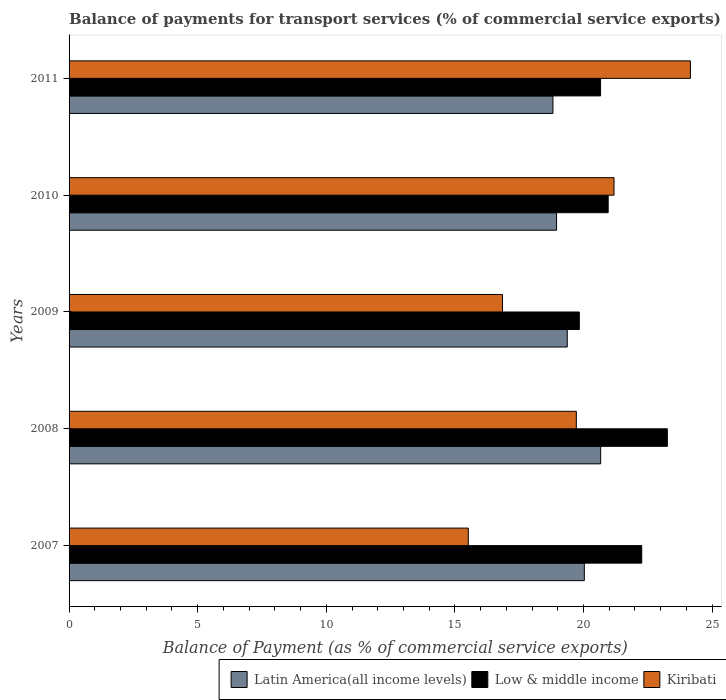How many different coloured bars are there?
Your response must be concise. 3. How many groups of bars are there?
Your answer should be compact. 5. Are the number of bars per tick equal to the number of legend labels?
Keep it short and to the point. Yes. How many bars are there on the 4th tick from the top?
Give a very brief answer. 3. What is the label of the 2nd group of bars from the top?
Offer a terse response. 2010. What is the balance of payments for transport services in Kiribati in 2011?
Offer a very short reply. 24.16. Across all years, what is the maximum balance of payments for transport services in Low & middle income?
Make the answer very short. 23.26. Across all years, what is the minimum balance of payments for transport services in Kiribati?
Keep it short and to the point. 15.52. What is the total balance of payments for transport services in Latin America(all income levels) in the graph?
Give a very brief answer. 97.83. What is the difference between the balance of payments for transport services in Latin America(all income levels) in 2008 and that in 2009?
Your answer should be compact. 1.3. What is the difference between the balance of payments for transport services in Low & middle income in 2011 and the balance of payments for transport services in Latin America(all income levels) in 2007?
Offer a terse response. 0.63. What is the average balance of payments for transport services in Latin America(all income levels) per year?
Your answer should be compact. 19.57. In the year 2007, what is the difference between the balance of payments for transport services in Kiribati and balance of payments for transport services in Low & middle income?
Offer a terse response. -6.74. In how many years, is the balance of payments for transport services in Kiribati greater than 2 %?
Make the answer very short. 5. What is the ratio of the balance of payments for transport services in Kiribati in 2007 to that in 2009?
Your response must be concise. 0.92. Is the balance of payments for transport services in Kiribati in 2007 less than that in 2009?
Offer a very short reply. Yes. What is the difference between the highest and the second highest balance of payments for transport services in Kiribati?
Your response must be concise. 2.97. What is the difference between the highest and the lowest balance of payments for transport services in Low & middle income?
Provide a succinct answer. 3.42. What does the 1st bar from the top in 2009 represents?
Offer a terse response. Kiribati. How many bars are there?
Provide a succinct answer. 15. Are all the bars in the graph horizontal?
Offer a terse response. Yes. How many years are there in the graph?
Offer a terse response. 5. What is the difference between two consecutive major ticks on the X-axis?
Provide a succinct answer. 5. What is the title of the graph?
Offer a terse response. Balance of payments for transport services (% of commercial service exports). Does "Chad" appear as one of the legend labels in the graph?
Give a very brief answer. No. What is the label or title of the X-axis?
Your response must be concise. Balance of Payment (as % of commercial service exports). What is the Balance of Payment (as % of commercial service exports) of Latin America(all income levels) in 2007?
Your answer should be compact. 20.03. What is the Balance of Payment (as % of commercial service exports) in Low & middle income in 2007?
Your response must be concise. 22.26. What is the Balance of Payment (as % of commercial service exports) in Kiribati in 2007?
Keep it short and to the point. 15.52. What is the Balance of Payment (as % of commercial service exports) in Latin America(all income levels) in 2008?
Offer a terse response. 20.67. What is the Balance of Payment (as % of commercial service exports) of Low & middle income in 2008?
Your answer should be very brief. 23.26. What is the Balance of Payment (as % of commercial service exports) in Kiribati in 2008?
Make the answer very short. 19.72. What is the Balance of Payment (as % of commercial service exports) in Latin America(all income levels) in 2009?
Ensure brevity in your answer.  19.37. What is the Balance of Payment (as % of commercial service exports) of Low & middle income in 2009?
Provide a short and direct response. 19.84. What is the Balance of Payment (as % of commercial service exports) of Kiribati in 2009?
Offer a terse response. 16.85. What is the Balance of Payment (as % of commercial service exports) in Latin America(all income levels) in 2010?
Provide a succinct answer. 18.95. What is the Balance of Payment (as % of commercial service exports) in Low & middle income in 2010?
Offer a very short reply. 20.96. What is the Balance of Payment (as % of commercial service exports) of Kiribati in 2010?
Your answer should be very brief. 21.19. What is the Balance of Payment (as % of commercial service exports) of Latin America(all income levels) in 2011?
Provide a succinct answer. 18.81. What is the Balance of Payment (as % of commercial service exports) in Low & middle income in 2011?
Provide a succinct answer. 20.66. What is the Balance of Payment (as % of commercial service exports) of Kiribati in 2011?
Ensure brevity in your answer.  24.16. Across all years, what is the maximum Balance of Payment (as % of commercial service exports) of Latin America(all income levels)?
Provide a succinct answer. 20.67. Across all years, what is the maximum Balance of Payment (as % of commercial service exports) of Low & middle income?
Your answer should be very brief. 23.26. Across all years, what is the maximum Balance of Payment (as % of commercial service exports) of Kiribati?
Keep it short and to the point. 24.16. Across all years, what is the minimum Balance of Payment (as % of commercial service exports) in Latin America(all income levels)?
Your answer should be compact. 18.81. Across all years, what is the minimum Balance of Payment (as % of commercial service exports) of Low & middle income?
Provide a short and direct response. 19.84. Across all years, what is the minimum Balance of Payment (as % of commercial service exports) of Kiribati?
Provide a short and direct response. 15.52. What is the total Balance of Payment (as % of commercial service exports) of Latin America(all income levels) in the graph?
Keep it short and to the point. 97.83. What is the total Balance of Payment (as % of commercial service exports) in Low & middle income in the graph?
Offer a very short reply. 106.98. What is the total Balance of Payment (as % of commercial service exports) of Kiribati in the graph?
Keep it short and to the point. 97.43. What is the difference between the Balance of Payment (as % of commercial service exports) in Latin America(all income levels) in 2007 and that in 2008?
Make the answer very short. -0.63. What is the difference between the Balance of Payment (as % of commercial service exports) of Low & middle income in 2007 and that in 2008?
Your response must be concise. -1. What is the difference between the Balance of Payment (as % of commercial service exports) of Kiribati in 2007 and that in 2008?
Make the answer very short. -4.2. What is the difference between the Balance of Payment (as % of commercial service exports) in Latin America(all income levels) in 2007 and that in 2009?
Provide a succinct answer. 0.66. What is the difference between the Balance of Payment (as % of commercial service exports) of Low & middle income in 2007 and that in 2009?
Offer a very short reply. 2.43. What is the difference between the Balance of Payment (as % of commercial service exports) of Kiribati in 2007 and that in 2009?
Your response must be concise. -1.33. What is the difference between the Balance of Payment (as % of commercial service exports) of Latin America(all income levels) in 2007 and that in 2010?
Keep it short and to the point. 1.08. What is the difference between the Balance of Payment (as % of commercial service exports) in Low & middle income in 2007 and that in 2010?
Offer a terse response. 1.3. What is the difference between the Balance of Payment (as % of commercial service exports) of Kiribati in 2007 and that in 2010?
Give a very brief answer. -5.67. What is the difference between the Balance of Payment (as % of commercial service exports) of Latin America(all income levels) in 2007 and that in 2011?
Give a very brief answer. 1.22. What is the difference between the Balance of Payment (as % of commercial service exports) in Low & middle income in 2007 and that in 2011?
Your response must be concise. 1.6. What is the difference between the Balance of Payment (as % of commercial service exports) in Kiribati in 2007 and that in 2011?
Provide a short and direct response. -8.64. What is the difference between the Balance of Payment (as % of commercial service exports) of Latin America(all income levels) in 2008 and that in 2009?
Offer a terse response. 1.3. What is the difference between the Balance of Payment (as % of commercial service exports) of Low & middle income in 2008 and that in 2009?
Your answer should be compact. 3.42. What is the difference between the Balance of Payment (as % of commercial service exports) in Kiribati in 2008 and that in 2009?
Offer a very short reply. 2.87. What is the difference between the Balance of Payment (as % of commercial service exports) in Latin America(all income levels) in 2008 and that in 2010?
Give a very brief answer. 1.71. What is the difference between the Balance of Payment (as % of commercial service exports) of Low & middle income in 2008 and that in 2010?
Provide a short and direct response. 2.3. What is the difference between the Balance of Payment (as % of commercial service exports) of Kiribati in 2008 and that in 2010?
Make the answer very short. -1.47. What is the difference between the Balance of Payment (as % of commercial service exports) of Latin America(all income levels) in 2008 and that in 2011?
Offer a very short reply. 1.85. What is the difference between the Balance of Payment (as % of commercial service exports) of Low & middle income in 2008 and that in 2011?
Keep it short and to the point. 2.6. What is the difference between the Balance of Payment (as % of commercial service exports) in Kiribati in 2008 and that in 2011?
Make the answer very short. -4.44. What is the difference between the Balance of Payment (as % of commercial service exports) of Latin America(all income levels) in 2009 and that in 2010?
Your response must be concise. 0.42. What is the difference between the Balance of Payment (as % of commercial service exports) of Low & middle income in 2009 and that in 2010?
Provide a short and direct response. -1.12. What is the difference between the Balance of Payment (as % of commercial service exports) in Kiribati in 2009 and that in 2010?
Make the answer very short. -4.33. What is the difference between the Balance of Payment (as % of commercial service exports) in Latin America(all income levels) in 2009 and that in 2011?
Offer a very short reply. 0.56. What is the difference between the Balance of Payment (as % of commercial service exports) of Low & middle income in 2009 and that in 2011?
Keep it short and to the point. -0.83. What is the difference between the Balance of Payment (as % of commercial service exports) in Kiribati in 2009 and that in 2011?
Provide a succinct answer. -7.3. What is the difference between the Balance of Payment (as % of commercial service exports) of Latin America(all income levels) in 2010 and that in 2011?
Your answer should be very brief. 0.14. What is the difference between the Balance of Payment (as % of commercial service exports) of Low & middle income in 2010 and that in 2011?
Your response must be concise. 0.29. What is the difference between the Balance of Payment (as % of commercial service exports) in Kiribati in 2010 and that in 2011?
Your answer should be compact. -2.97. What is the difference between the Balance of Payment (as % of commercial service exports) in Latin America(all income levels) in 2007 and the Balance of Payment (as % of commercial service exports) in Low & middle income in 2008?
Give a very brief answer. -3.23. What is the difference between the Balance of Payment (as % of commercial service exports) in Latin America(all income levels) in 2007 and the Balance of Payment (as % of commercial service exports) in Kiribati in 2008?
Give a very brief answer. 0.31. What is the difference between the Balance of Payment (as % of commercial service exports) of Low & middle income in 2007 and the Balance of Payment (as % of commercial service exports) of Kiribati in 2008?
Your response must be concise. 2.54. What is the difference between the Balance of Payment (as % of commercial service exports) of Latin America(all income levels) in 2007 and the Balance of Payment (as % of commercial service exports) of Low & middle income in 2009?
Your answer should be very brief. 0.2. What is the difference between the Balance of Payment (as % of commercial service exports) in Latin America(all income levels) in 2007 and the Balance of Payment (as % of commercial service exports) in Kiribati in 2009?
Your answer should be very brief. 3.18. What is the difference between the Balance of Payment (as % of commercial service exports) of Low & middle income in 2007 and the Balance of Payment (as % of commercial service exports) of Kiribati in 2009?
Your answer should be very brief. 5.41. What is the difference between the Balance of Payment (as % of commercial service exports) in Latin America(all income levels) in 2007 and the Balance of Payment (as % of commercial service exports) in Low & middle income in 2010?
Give a very brief answer. -0.93. What is the difference between the Balance of Payment (as % of commercial service exports) in Latin America(all income levels) in 2007 and the Balance of Payment (as % of commercial service exports) in Kiribati in 2010?
Ensure brevity in your answer.  -1.15. What is the difference between the Balance of Payment (as % of commercial service exports) of Low & middle income in 2007 and the Balance of Payment (as % of commercial service exports) of Kiribati in 2010?
Offer a terse response. 1.08. What is the difference between the Balance of Payment (as % of commercial service exports) in Latin America(all income levels) in 2007 and the Balance of Payment (as % of commercial service exports) in Low & middle income in 2011?
Your answer should be compact. -0.63. What is the difference between the Balance of Payment (as % of commercial service exports) in Latin America(all income levels) in 2007 and the Balance of Payment (as % of commercial service exports) in Kiribati in 2011?
Your answer should be compact. -4.12. What is the difference between the Balance of Payment (as % of commercial service exports) in Low & middle income in 2007 and the Balance of Payment (as % of commercial service exports) in Kiribati in 2011?
Offer a terse response. -1.89. What is the difference between the Balance of Payment (as % of commercial service exports) of Latin America(all income levels) in 2008 and the Balance of Payment (as % of commercial service exports) of Low & middle income in 2009?
Give a very brief answer. 0.83. What is the difference between the Balance of Payment (as % of commercial service exports) in Latin America(all income levels) in 2008 and the Balance of Payment (as % of commercial service exports) in Kiribati in 2009?
Your response must be concise. 3.81. What is the difference between the Balance of Payment (as % of commercial service exports) in Low & middle income in 2008 and the Balance of Payment (as % of commercial service exports) in Kiribati in 2009?
Offer a terse response. 6.41. What is the difference between the Balance of Payment (as % of commercial service exports) of Latin America(all income levels) in 2008 and the Balance of Payment (as % of commercial service exports) of Low & middle income in 2010?
Make the answer very short. -0.29. What is the difference between the Balance of Payment (as % of commercial service exports) of Latin America(all income levels) in 2008 and the Balance of Payment (as % of commercial service exports) of Kiribati in 2010?
Keep it short and to the point. -0.52. What is the difference between the Balance of Payment (as % of commercial service exports) in Low & middle income in 2008 and the Balance of Payment (as % of commercial service exports) in Kiribati in 2010?
Provide a succinct answer. 2.07. What is the difference between the Balance of Payment (as % of commercial service exports) in Latin America(all income levels) in 2008 and the Balance of Payment (as % of commercial service exports) in Low & middle income in 2011?
Provide a succinct answer. 0. What is the difference between the Balance of Payment (as % of commercial service exports) of Latin America(all income levels) in 2008 and the Balance of Payment (as % of commercial service exports) of Kiribati in 2011?
Give a very brief answer. -3.49. What is the difference between the Balance of Payment (as % of commercial service exports) in Low & middle income in 2008 and the Balance of Payment (as % of commercial service exports) in Kiribati in 2011?
Offer a very short reply. -0.9. What is the difference between the Balance of Payment (as % of commercial service exports) in Latin America(all income levels) in 2009 and the Balance of Payment (as % of commercial service exports) in Low & middle income in 2010?
Your answer should be very brief. -1.59. What is the difference between the Balance of Payment (as % of commercial service exports) in Latin America(all income levels) in 2009 and the Balance of Payment (as % of commercial service exports) in Kiribati in 2010?
Your answer should be compact. -1.82. What is the difference between the Balance of Payment (as % of commercial service exports) in Low & middle income in 2009 and the Balance of Payment (as % of commercial service exports) in Kiribati in 2010?
Make the answer very short. -1.35. What is the difference between the Balance of Payment (as % of commercial service exports) of Latin America(all income levels) in 2009 and the Balance of Payment (as % of commercial service exports) of Low & middle income in 2011?
Ensure brevity in your answer.  -1.3. What is the difference between the Balance of Payment (as % of commercial service exports) in Latin America(all income levels) in 2009 and the Balance of Payment (as % of commercial service exports) in Kiribati in 2011?
Your response must be concise. -4.79. What is the difference between the Balance of Payment (as % of commercial service exports) of Low & middle income in 2009 and the Balance of Payment (as % of commercial service exports) of Kiribati in 2011?
Your answer should be very brief. -4.32. What is the difference between the Balance of Payment (as % of commercial service exports) in Latin America(all income levels) in 2010 and the Balance of Payment (as % of commercial service exports) in Low & middle income in 2011?
Ensure brevity in your answer.  -1.71. What is the difference between the Balance of Payment (as % of commercial service exports) of Latin America(all income levels) in 2010 and the Balance of Payment (as % of commercial service exports) of Kiribati in 2011?
Your answer should be compact. -5.2. What is the difference between the Balance of Payment (as % of commercial service exports) of Low & middle income in 2010 and the Balance of Payment (as % of commercial service exports) of Kiribati in 2011?
Keep it short and to the point. -3.2. What is the average Balance of Payment (as % of commercial service exports) of Latin America(all income levels) per year?
Provide a short and direct response. 19.57. What is the average Balance of Payment (as % of commercial service exports) in Low & middle income per year?
Keep it short and to the point. 21.4. What is the average Balance of Payment (as % of commercial service exports) in Kiribati per year?
Offer a terse response. 19.49. In the year 2007, what is the difference between the Balance of Payment (as % of commercial service exports) of Latin America(all income levels) and Balance of Payment (as % of commercial service exports) of Low & middle income?
Keep it short and to the point. -2.23. In the year 2007, what is the difference between the Balance of Payment (as % of commercial service exports) of Latin America(all income levels) and Balance of Payment (as % of commercial service exports) of Kiribati?
Offer a very short reply. 4.51. In the year 2007, what is the difference between the Balance of Payment (as % of commercial service exports) of Low & middle income and Balance of Payment (as % of commercial service exports) of Kiribati?
Provide a succinct answer. 6.74. In the year 2008, what is the difference between the Balance of Payment (as % of commercial service exports) of Latin America(all income levels) and Balance of Payment (as % of commercial service exports) of Low & middle income?
Offer a terse response. -2.59. In the year 2008, what is the difference between the Balance of Payment (as % of commercial service exports) of Latin America(all income levels) and Balance of Payment (as % of commercial service exports) of Kiribati?
Provide a short and direct response. 0.95. In the year 2008, what is the difference between the Balance of Payment (as % of commercial service exports) in Low & middle income and Balance of Payment (as % of commercial service exports) in Kiribati?
Your answer should be compact. 3.54. In the year 2009, what is the difference between the Balance of Payment (as % of commercial service exports) of Latin America(all income levels) and Balance of Payment (as % of commercial service exports) of Low & middle income?
Your answer should be very brief. -0.47. In the year 2009, what is the difference between the Balance of Payment (as % of commercial service exports) of Latin America(all income levels) and Balance of Payment (as % of commercial service exports) of Kiribati?
Give a very brief answer. 2.52. In the year 2009, what is the difference between the Balance of Payment (as % of commercial service exports) of Low & middle income and Balance of Payment (as % of commercial service exports) of Kiribati?
Your answer should be compact. 2.99. In the year 2010, what is the difference between the Balance of Payment (as % of commercial service exports) in Latin America(all income levels) and Balance of Payment (as % of commercial service exports) in Low & middle income?
Provide a short and direct response. -2.01. In the year 2010, what is the difference between the Balance of Payment (as % of commercial service exports) in Latin America(all income levels) and Balance of Payment (as % of commercial service exports) in Kiribati?
Ensure brevity in your answer.  -2.23. In the year 2010, what is the difference between the Balance of Payment (as % of commercial service exports) of Low & middle income and Balance of Payment (as % of commercial service exports) of Kiribati?
Give a very brief answer. -0.23. In the year 2011, what is the difference between the Balance of Payment (as % of commercial service exports) of Latin America(all income levels) and Balance of Payment (as % of commercial service exports) of Low & middle income?
Your answer should be very brief. -1.85. In the year 2011, what is the difference between the Balance of Payment (as % of commercial service exports) in Latin America(all income levels) and Balance of Payment (as % of commercial service exports) in Kiribati?
Provide a short and direct response. -5.34. In the year 2011, what is the difference between the Balance of Payment (as % of commercial service exports) in Low & middle income and Balance of Payment (as % of commercial service exports) in Kiribati?
Offer a terse response. -3.49. What is the ratio of the Balance of Payment (as % of commercial service exports) in Latin America(all income levels) in 2007 to that in 2008?
Your response must be concise. 0.97. What is the ratio of the Balance of Payment (as % of commercial service exports) in Low & middle income in 2007 to that in 2008?
Keep it short and to the point. 0.96. What is the ratio of the Balance of Payment (as % of commercial service exports) in Kiribati in 2007 to that in 2008?
Give a very brief answer. 0.79. What is the ratio of the Balance of Payment (as % of commercial service exports) in Latin America(all income levels) in 2007 to that in 2009?
Provide a succinct answer. 1.03. What is the ratio of the Balance of Payment (as % of commercial service exports) of Low & middle income in 2007 to that in 2009?
Ensure brevity in your answer.  1.12. What is the ratio of the Balance of Payment (as % of commercial service exports) of Kiribati in 2007 to that in 2009?
Ensure brevity in your answer.  0.92. What is the ratio of the Balance of Payment (as % of commercial service exports) in Latin America(all income levels) in 2007 to that in 2010?
Provide a succinct answer. 1.06. What is the ratio of the Balance of Payment (as % of commercial service exports) of Low & middle income in 2007 to that in 2010?
Offer a terse response. 1.06. What is the ratio of the Balance of Payment (as % of commercial service exports) in Kiribati in 2007 to that in 2010?
Your answer should be compact. 0.73. What is the ratio of the Balance of Payment (as % of commercial service exports) of Latin America(all income levels) in 2007 to that in 2011?
Give a very brief answer. 1.06. What is the ratio of the Balance of Payment (as % of commercial service exports) of Low & middle income in 2007 to that in 2011?
Provide a succinct answer. 1.08. What is the ratio of the Balance of Payment (as % of commercial service exports) of Kiribati in 2007 to that in 2011?
Make the answer very short. 0.64. What is the ratio of the Balance of Payment (as % of commercial service exports) in Latin America(all income levels) in 2008 to that in 2009?
Offer a terse response. 1.07. What is the ratio of the Balance of Payment (as % of commercial service exports) in Low & middle income in 2008 to that in 2009?
Offer a very short reply. 1.17. What is the ratio of the Balance of Payment (as % of commercial service exports) of Kiribati in 2008 to that in 2009?
Your answer should be very brief. 1.17. What is the ratio of the Balance of Payment (as % of commercial service exports) of Latin America(all income levels) in 2008 to that in 2010?
Offer a very short reply. 1.09. What is the ratio of the Balance of Payment (as % of commercial service exports) of Low & middle income in 2008 to that in 2010?
Make the answer very short. 1.11. What is the ratio of the Balance of Payment (as % of commercial service exports) of Kiribati in 2008 to that in 2010?
Ensure brevity in your answer.  0.93. What is the ratio of the Balance of Payment (as % of commercial service exports) in Latin America(all income levels) in 2008 to that in 2011?
Provide a succinct answer. 1.1. What is the ratio of the Balance of Payment (as % of commercial service exports) of Low & middle income in 2008 to that in 2011?
Make the answer very short. 1.13. What is the ratio of the Balance of Payment (as % of commercial service exports) of Kiribati in 2008 to that in 2011?
Make the answer very short. 0.82. What is the ratio of the Balance of Payment (as % of commercial service exports) in Latin America(all income levels) in 2009 to that in 2010?
Keep it short and to the point. 1.02. What is the ratio of the Balance of Payment (as % of commercial service exports) in Low & middle income in 2009 to that in 2010?
Your answer should be very brief. 0.95. What is the ratio of the Balance of Payment (as % of commercial service exports) in Kiribati in 2009 to that in 2010?
Provide a short and direct response. 0.8. What is the ratio of the Balance of Payment (as % of commercial service exports) in Latin America(all income levels) in 2009 to that in 2011?
Your response must be concise. 1.03. What is the ratio of the Balance of Payment (as % of commercial service exports) in Low & middle income in 2009 to that in 2011?
Keep it short and to the point. 0.96. What is the ratio of the Balance of Payment (as % of commercial service exports) in Kiribati in 2009 to that in 2011?
Provide a succinct answer. 0.7. What is the ratio of the Balance of Payment (as % of commercial service exports) of Latin America(all income levels) in 2010 to that in 2011?
Your answer should be very brief. 1.01. What is the ratio of the Balance of Payment (as % of commercial service exports) of Low & middle income in 2010 to that in 2011?
Offer a terse response. 1.01. What is the ratio of the Balance of Payment (as % of commercial service exports) in Kiribati in 2010 to that in 2011?
Keep it short and to the point. 0.88. What is the difference between the highest and the second highest Balance of Payment (as % of commercial service exports) in Latin America(all income levels)?
Offer a terse response. 0.63. What is the difference between the highest and the second highest Balance of Payment (as % of commercial service exports) of Low & middle income?
Make the answer very short. 1. What is the difference between the highest and the second highest Balance of Payment (as % of commercial service exports) in Kiribati?
Keep it short and to the point. 2.97. What is the difference between the highest and the lowest Balance of Payment (as % of commercial service exports) of Latin America(all income levels)?
Your response must be concise. 1.85. What is the difference between the highest and the lowest Balance of Payment (as % of commercial service exports) in Low & middle income?
Your response must be concise. 3.42. What is the difference between the highest and the lowest Balance of Payment (as % of commercial service exports) in Kiribati?
Provide a succinct answer. 8.64. 